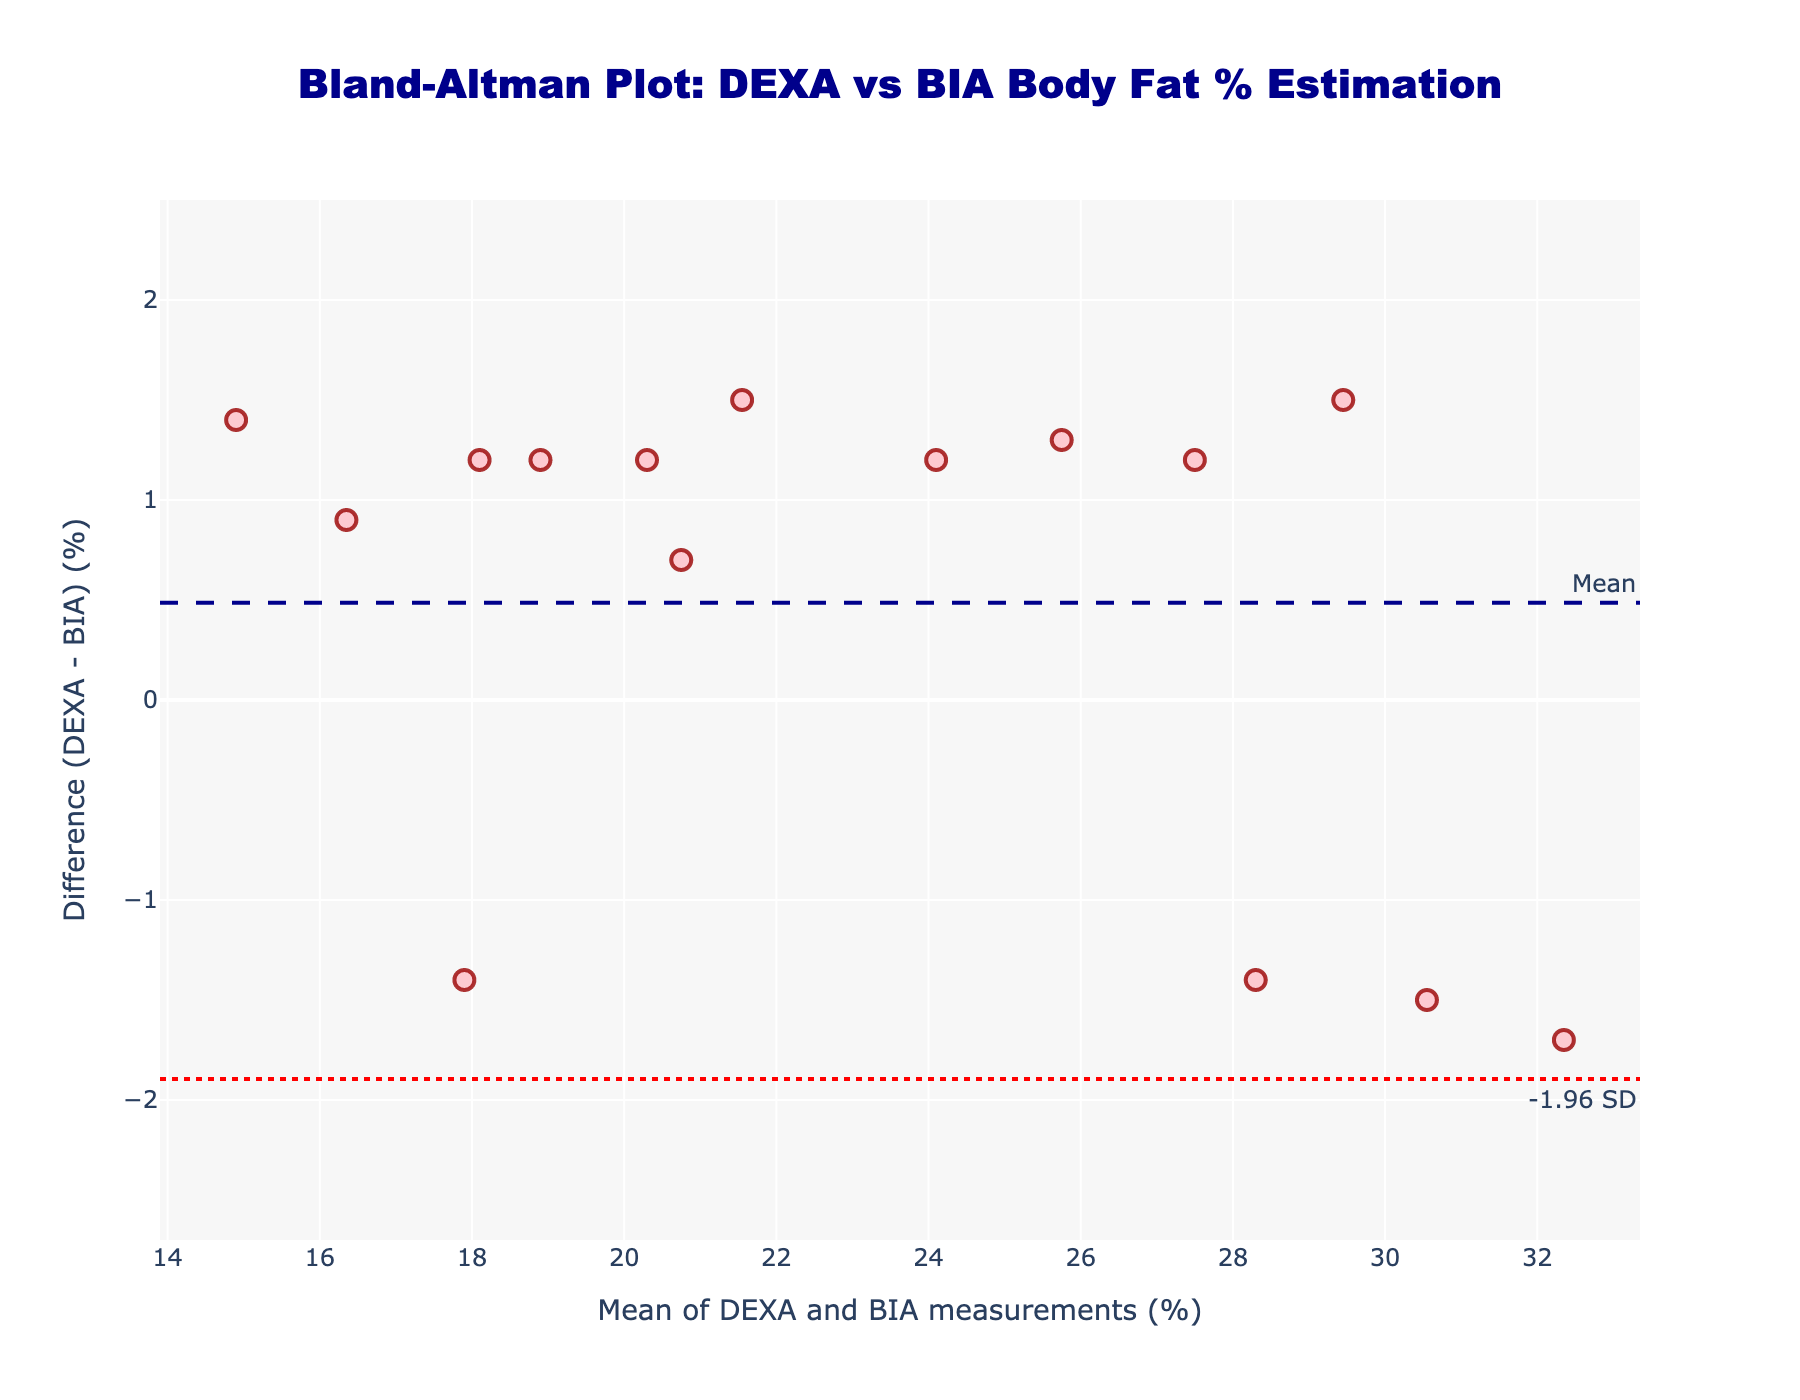What's the title of the plot? The title of the plot is usually the most prominent text at the top of the figure. Here, it reads "Bland-Altman Plot: DEXA vs BIA Body Fat % Estimation"
Answer: Bland-Altman Plot: DEXA vs BIA Body Fat % Estimation What are the x-axis and y-axis labels? Axis labels are usually located adjacent to the respective axes to describe the data plotted. For the x-axis, it is "Mean of DEXA and BIA measurements (%)". For the y-axis, it is "Difference (DEXA - BIA) (%)".
Answer: x-axis: Mean of DEXA and BIA measurements (%), y-axis: Difference (DEXA - BIA) (%) How many data points are plotted in the figure? Data points are represented as markers in the plot. You can count each colored marker to determine the total number.
Answer: 15 What is the mean difference between DEXA and BIA measurements, as shown in the plot? The mean difference line is usually a horizontal dashed line with an annotated label. Here, it is marked by a line at a specified y-value and annotated as "Mean".
Answer: Around 0.4 What are the upper and lower limits of agreement (LoA) in the plot? The limits of agreement (LoA) are depicted by horizontal dotted lines usually labeled "+1.96 SD" for the upper LoA and "-1.96 SD" for the lower LoA. The y-values of these lines give the upper and lower LoA.
Answer: Upper LoA: Around 2.3, Lower LoA: Around -1.5 Based on the plotted points, is the estimation method (BIA) generally overestimating or underestimating body fat percentage compared to DEXA? To determine this, observe the general positions of the data points relative to the y=0 line on the plot. If most points are above the line, BIA is underestimating; if below, overestimating.
Answer: Slightly underestimating Which subject has the greatest discrepancy between DEXA and BIA measurements? To find the subject with the greatest discrepancy, look for the data point farthest from the y=0 line. Compare the subject’s difference between the DEXA and BIA measurements.
Answer: Olivia Thompson Is there a significant trend in the differences as the mean body fat percentage increases? To evaluate this, observe whether the differences (y-coordinates) systematically increase or decrease as one moves along the x-axis (mean body fat percentage). Presence of a trend would indicate a pattern.
Answer: No significant trend is obvious Do any data points lie outside the 95% limits of agreement? Compare the data points' y-coordinates to the upper and lower LoA lines. Points outside these lines lie outside the 95% limits of agreement.
Answer: No Which subject has a difference between DEXA and BIA closest to the mean difference? Find the data point whose y-coordinate (difference) is closest to the dashed mean difference line annotated as "Mean". Then identify the corresponding subject.
Answer: Daniel Brown 